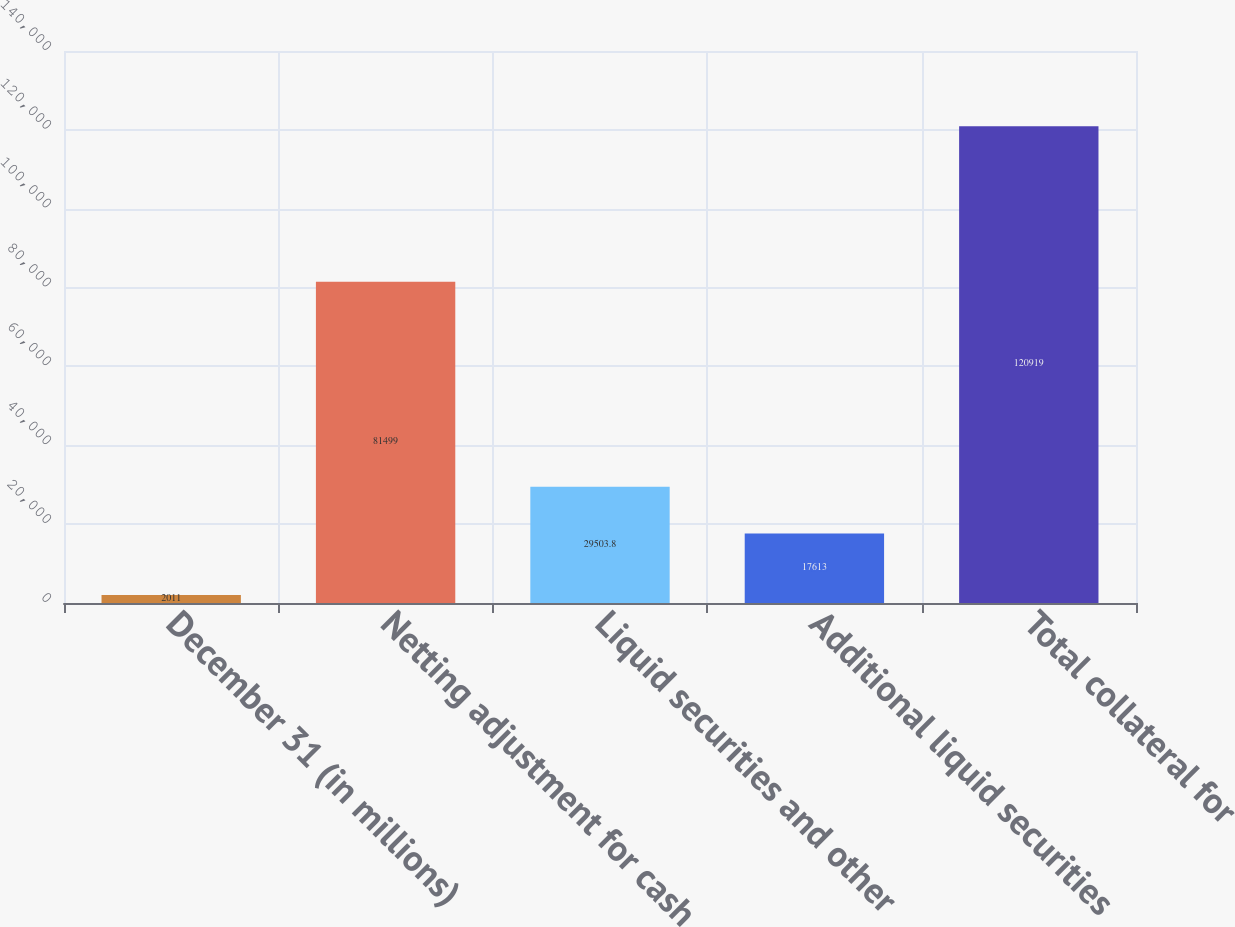<chart> <loc_0><loc_0><loc_500><loc_500><bar_chart><fcel>December 31 (in millions)<fcel>Netting adjustment for cash<fcel>Liquid securities and other<fcel>Additional liquid securities<fcel>Total collateral for<nl><fcel>2011<fcel>81499<fcel>29503.8<fcel>17613<fcel>120919<nl></chart> 